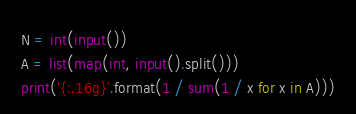Convert code to text. <code><loc_0><loc_0><loc_500><loc_500><_Python_>N = int(input())
A = list(map(int, input().split()))
print('{:.16g}'.format(1 / sum(1 / x for x in A)))
</code> 